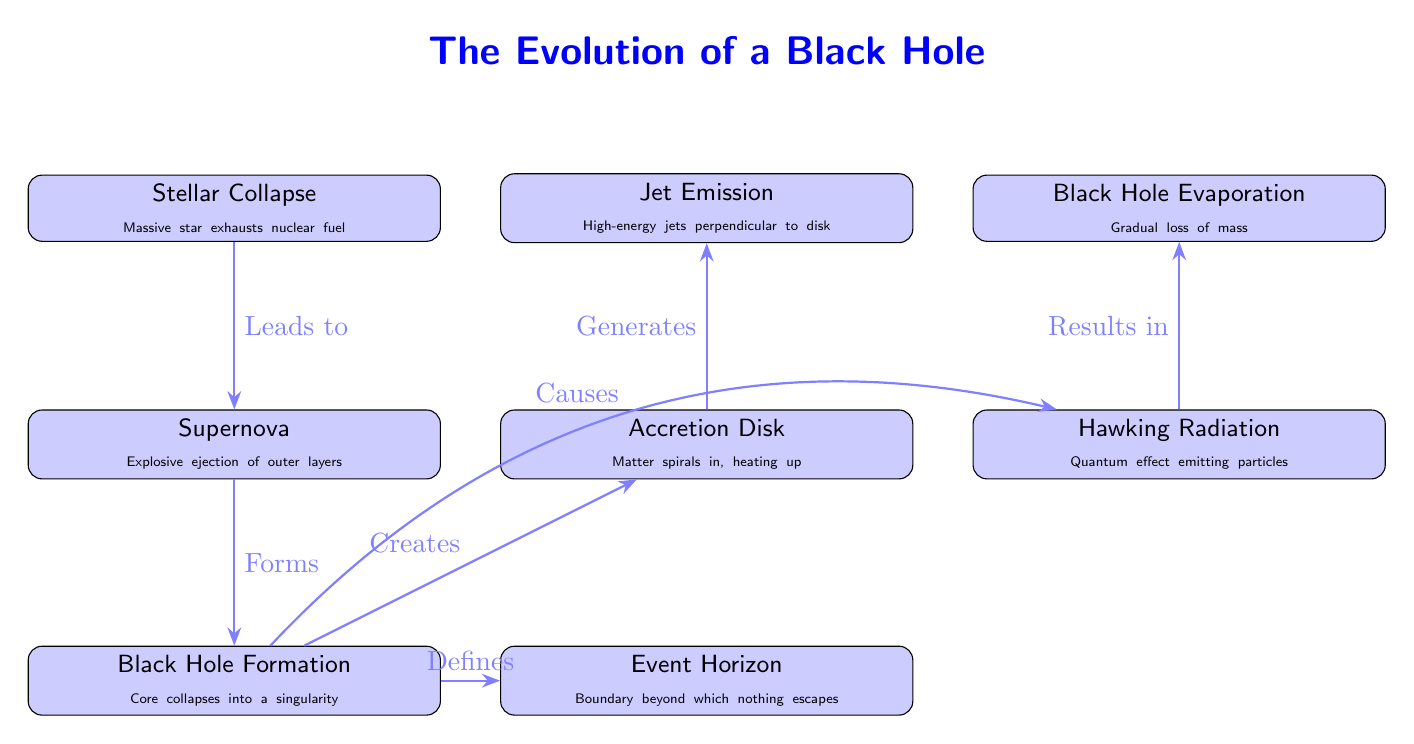What initiates the black hole evolution process? The process begins with "Stellar Collapse," which is marked as the first event in the diagram leading to subsequent stages.
Answer: Stellar Collapse How many main events are depicted in the diagram? By counting the nodes labeled as events, we identify a total of 7 main events that depict the evolution of a black hole.
Answer: 7 What forms from the supernova event? The arrow from "Supernova" points to "Black Hole Formation," indicating that this step is the direct result of the supernova.
Answer: Black Hole Formation What is created alongside black hole formation? The diagram shows an arrow from "Black Hole Formation" to "Accretion Disk," indicating that the accretion disk is created simultaneously with black hole formation.
Answer: Accretion Disk What does Hawking Radiation lead to eventually? According to the diagram, Hawking Radiation leads to "Black Hole Evaporation," shown by the directed arrow in the flow of events.
Answer: Black Hole Evaporation Which event describes high-energy jets? The event labeled "Jet Emission" is specifically defined as the emission of high-energy jets and is connected through the "Accretion Disk."
Answer: Jet Emission What is the relationship between black hole formation and the event horizon? The arrow from "Black Hole Formation" to "Event Horizon" in the diagram indicates that the formation of a black hole defines the event horizon.
Answer: Defines What actions are happening in the accretion disk? The "Accretion Disk" event is described as matter spiraling in and heating up, which is the process occurring there.
Answer: Spiraling in, heating up What is the cause of Hawking Radiation? The diagram indicates that "Black Hole Formation" causes Hawking Radiation, establishing a direct causal link in the events.
Answer: Causes 